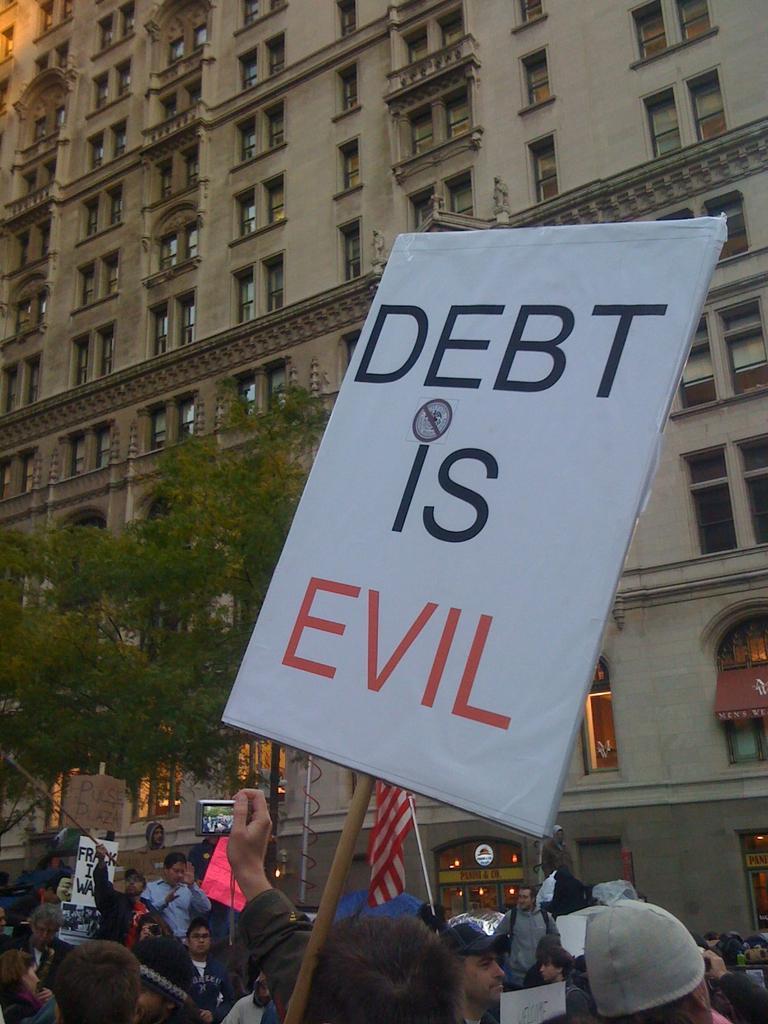In one or two sentences, can you explain what this image depicts? In this picture we can see few people. We can see few posts and a flag. There is a building and few trees. We can see a pole and a wire. 